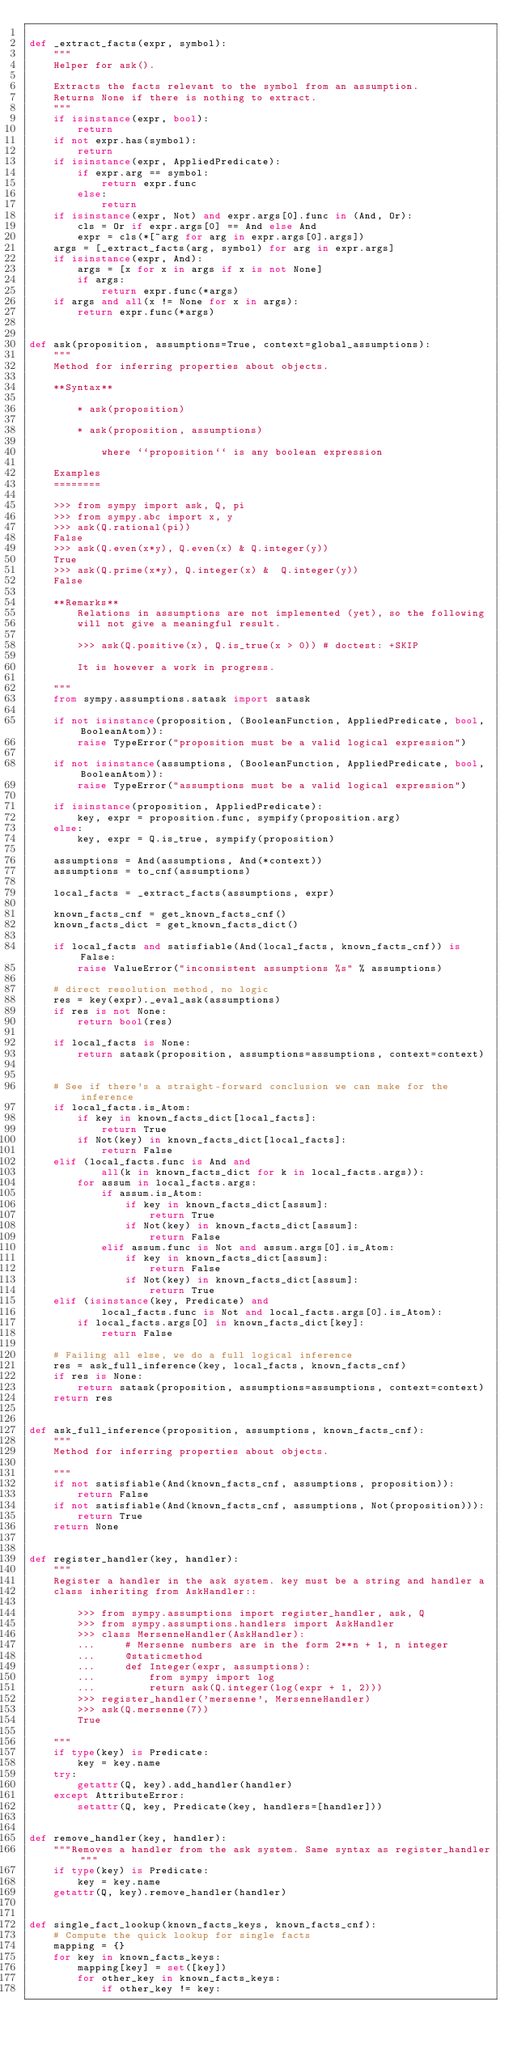<code> <loc_0><loc_0><loc_500><loc_500><_Python_>
def _extract_facts(expr, symbol):
    """
    Helper for ask().

    Extracts the facts relevant to the symbol from an assumption.
    Returns None if there is nothing to extract.
    """
    if isinstance(expr, bool):
        return
    if not expr.has(symbol):
        return
    if isinstance(expr, AppliedPredicate):
        if expr.arg == symbol:
            return expr.func
        else:
            return
    if isinstance(expr, Not) and expr.args[0].func in (And, Or):
        cls = Or if expr.args[0] == And else And
        expr = cls(*[~arg for arg in expr.args[0].args])
    args = [_extract_facts(arg, symbol) for arg in expr.args]
    if isinstance(expr, And):
        args = [x for x in args if x is not None]
        if args:
            return expr.func(*args)
    if args and all(x != None for x in args):
        return expr.func(*args)


def ask(proposition, assumptions=True, context=global_assumptions):
    """
    Method for inferring properties about objects.

    **Syntax**

        * ask(proposition)

        * ask(proposition, assumptions)

            where ``proposition`` is any boolean expression

    Examples
    ========

    >>> from sympy import ask, Q, pi
    >>> from sympy.abc import x, y
    >>> ask(Q.rational(pi))
    False
    >>> ask(Q.even(x*y), Q.even(x) & Q.integer(y))
    True
    >>> ask(Q.prime(x*y), Q.integer(x) &  Q.integer(y))
    False

    **Remarks**
        Relations in assumptions are not implemented (yet), so the following
        will not give a meaningful result.

        >>> ask(Q.positive(x), Q.is_true(x > 0)) # doctest: +SKIP

        It is however a work in progress.

    """
    from sympy.assumptions.satask import satask

    if not isinstance(proposition, (BooleanFunction, AppliedPredicate, bool, BooleanAtom)):
        raise TypeError("proposition must be a valid logical expression")

    if not isinstance(assumptions, (BooleanFunction, AppliedPredicate, bool, BooleanAtom)):
        raise TypeError("assumptions must be a valid logical expression")

    if isinstance(proposition, AppliedPredicate):
        key, expr = proposition.func, sympify(proposition.arg)
    else:
        key, expr = Q.is_true, sympify(proposition)

    assumptions = And(assumptions, And(*context))
    assumptions = to_cnf(assumptions)

    local_facts = _extract_facts(assumptions, expr)

    known_facts_cnf = get_known_facts_cnf()
    known_facts_dict = get_known_facts_dict()

    if local_facts and satisfiable(And(local_facts, known_facts_cnf)) is False:
        raise ValueError("inconsistent assumptions %s" % assumptions)

    # direct resolution method, no logic
    res = key(expr)._eval_ask(assumptions)
    if res is not None:
        return bool(res)

    if local_facts is None:
        return satask(proposition, assumptions=assumptions, context=context)


    # See if there's a straight-forward conclusion we can make for the inference
    if local_facts.is_Atom:
        if key in known_facts_dict[local_facts]:
            return True
        if Not(key) in known_facts_dict[local_facts]:
            return False
    elif (local_facts.func is And and
            all(k in known_facts_dict for k in local_facts.args)):
        for assum in local_facts.args:
            if assum.is_Atom:
                if key in known_facts_dict[assum]:
                    return True
                if Not(key) in known_facts_dict[assum]:
                    return False
            elif assum.func is Not and assum.args[0].is_Atom:
                if key in known_facts_dict[assum]:
                    return False
                if Not(key) in known_facts_dict[assum]:
                    return True
    elif (isinstance(key, Predicate) and
            local_facts.func is Not and local_facts.args[0].is_Atom):
        if local_facts.args[0] in known_facts_dict[key]:
            return False

    # Failing all else, we do a full logical inference
    res = ask_full_inference(key, local_facts, known_facts_cnf)
    if res is None:
        return satask(proposition, assumptions=assumptions, context=context)
    return res


def ask_full_inference(proposition, assumptions, known_facts_cnf):
    """
    Method for inferring properties about objects.

    """
    if not satisfiable(And(known_facts_cnf, assumptions, proposition)):
        return False
    if not satisfiable(And(known_facts_cnf, assumptions, Not(proposition))):
        return True
    return None


def register_handler(key, handler):
    """
    Register a handler in the ask system. key must be a string and handler a
    class inheriting from AskHandler::

        >>> from sympy.assumptions import register_handler, ask, Q
        >>> from sympy.assumptions.handlers import AskHandler
        >>> class MersenneHandler(AskHandler):
        ...     # Mersenne numbers are in the form 2**n + 1, n integer
        ...     @staticmethod
        ...     def Integer(expr, assumptions):
        ...         from sympy import log
        ...         return ask(Q.integer(log(expr + 1, 2)))
        >>> register_handler('mersenne', MersenneHandler)
        >>> ask(Q.mersenne(7))
        True

    """
    if type(key) is Predicate:
        key = key.name
    try:
        getattr(Q, key).add_handler(handler)
    except AttributeError:
        setattr(Q, key, Predicate(key, handlers=[handler]))


def remove_handler(key, handler):
    """Removes a handler from the ask system. Same syntax as register_handler"""
    if type(key) is Predicate:
        key = key.name
    getattr(Q, key).remove_handler(handler)


def single_fact_lookup(known_facts_keys, known_facts_cnf):
    # Compute the quick lookup for single facts
    mapping = {}
    for key in known_facts_keys:
        mapping[key] = set([key])
        for other_key in known_facts_keys:
            if other_key != key:</code> 